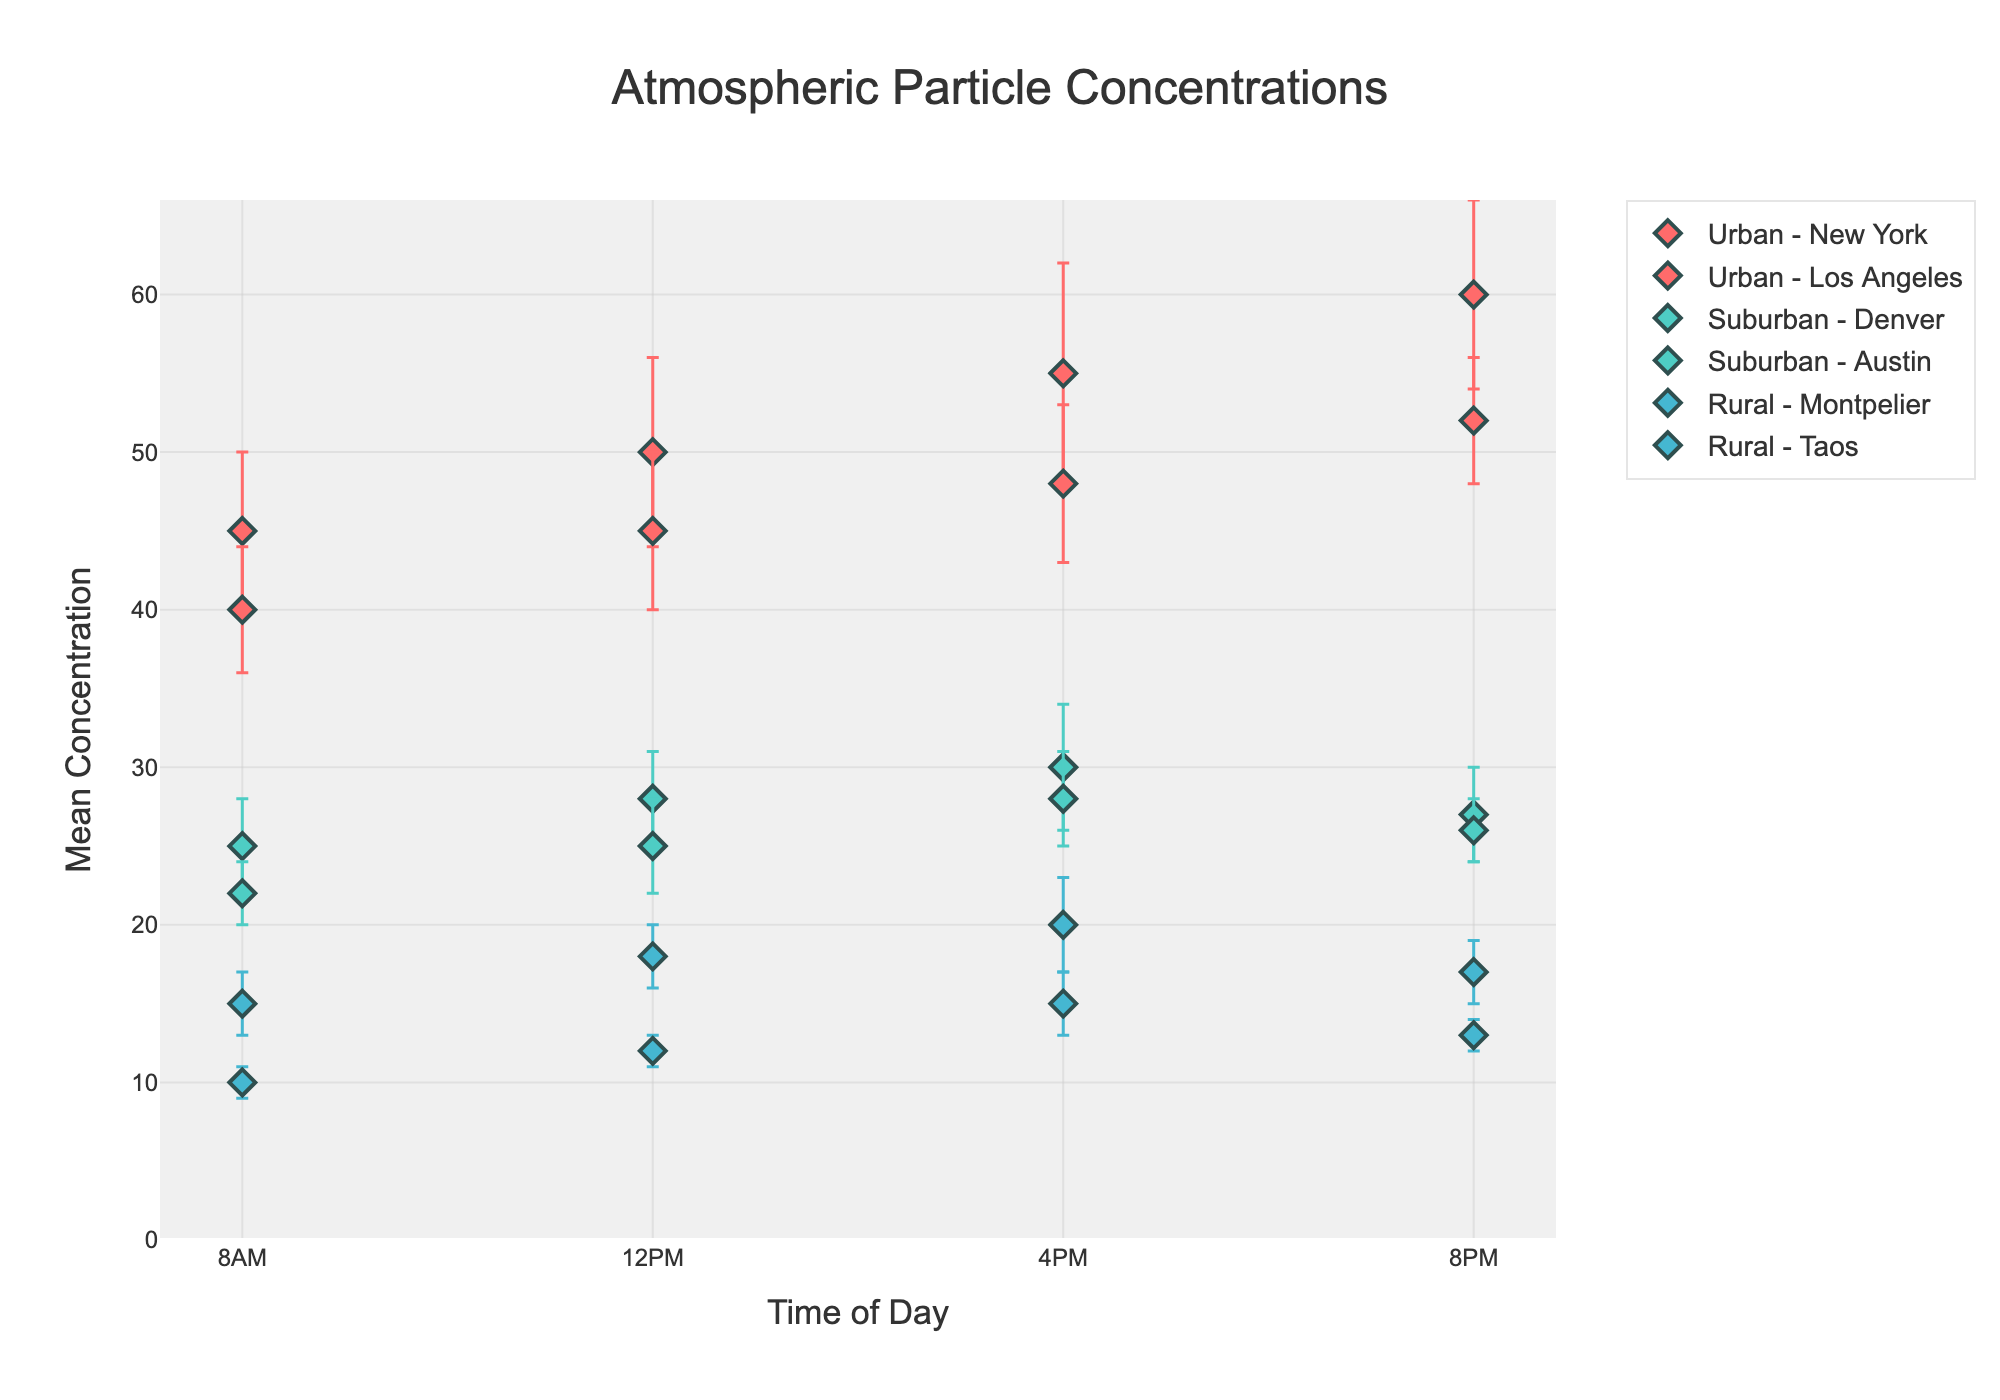What is the mean concentration of particles in New York at 8 PM? The error bars indicate the standard deviation and the markers show the mean. According to the figure, the mean concentration of particles in New York at 8 PM is displayed.
Answer: 60 How do the concentrations in Los Angeles change from 8 AM to 8 PM? To determine the change, observe each data point for Los Angeles at 8 AM, 12 PM, 4 PM, and 8 PM. At 8 AM, the concentration is 40, increasing to 45 at 12 PM, 48 at 4 PM, and finally 52 at 8 PM.
Answer: Increase What’s the difference in mean particle concentrations between Denver and Austin at 12 PM? Look at both locations at 12 PM on the plot. Denver has a mean concentration of 28, and Austin has a mean concentration of 25. The difference is calculated as 28 - 25.
Answer: 3 Which rural location shows the least variation in atmospheric particle concentration? Assess the error bars for Montpelier and Taos. Taos has smaller error bars, indicating less variation.
Answer: Taos Which time of day shows the highest concentration in urban environments? Check the concentrations for New York and Los Angeles at all times. Both locations peak in concentration at 8 PM with New York at 60 and Los Angeles at 52.
Answer: 8 PM Considering the entirety of the data, do rural or suburban environments show greater mean values in the afternoon (4 PM)? Look at the mean concentrations for Denver and Austin at 4 PM and compare them with Montpelier and Taos at the same time. Denver records 30, Austin 28, Montpelier 20, and Taos 15. Suburban environments have greater mean values.
Answer: Suburban Which environment generally has the highest mean particle concentrations? Compare the mean concentrations across urban, suburban, and rural environments. Urban environments generally have higher mean concentrations compared to suburban and rural ones.
Answer: Urban At which times do the particle concentrations overlap considerably between New York and Los Angeles? Examine overlapping error bars for New York and Los Angeles. They overlap at 8 AM, 12 PM, and 4 PM but not at 8 PM.
Answer: 8 AM, 12 PM, 4 PM 